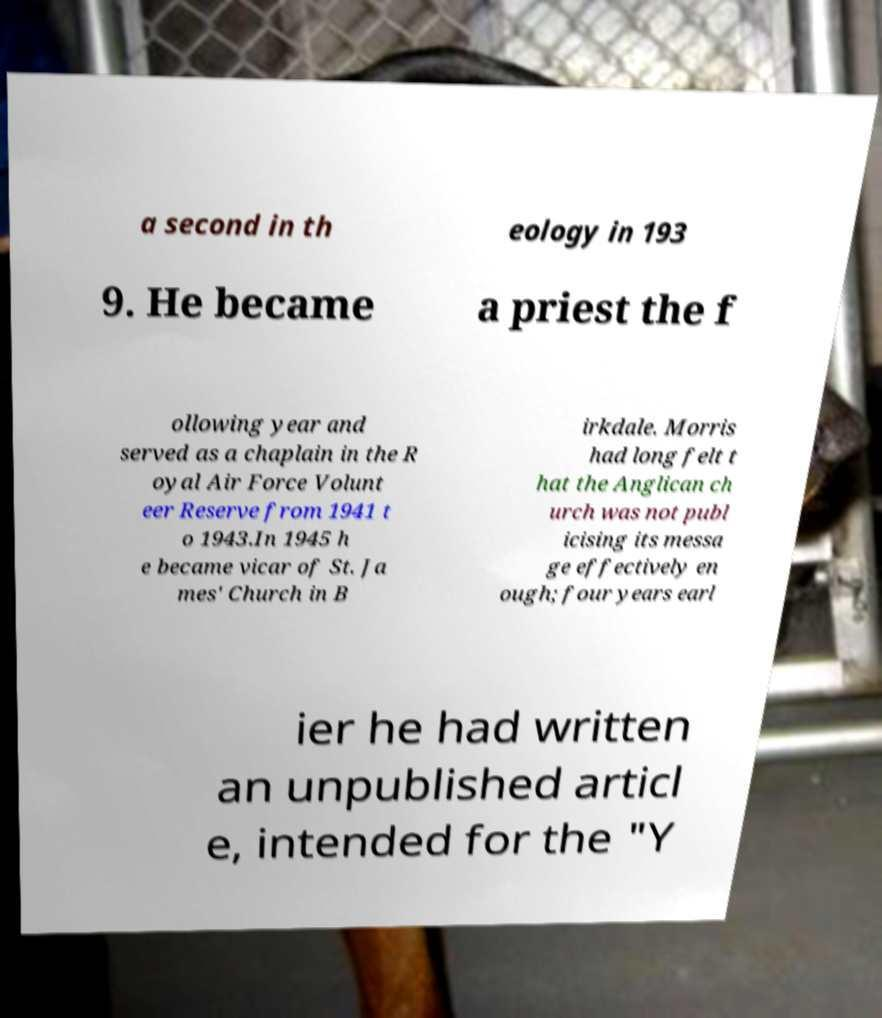Can you accurately transcribe the text from the provided image for me? a second in th eology in 193 9. He became a priest the f ollowing year and served as a chaplain in the R oyal Air Force Volunt eer Reserve from 1941 t o 1943.In 1945 h e became vicar of St. Ja mes' Church in B irkdale. Morris had long felt t hat the Anglican ch urch was not publ icising its messa ge effectively en ough; four years earl ier he had written an unpublished articl e, intended for the "Y 